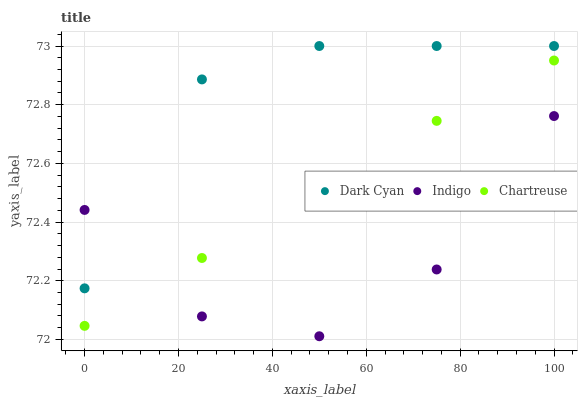Does Indigo have the minimum area under the curve?
Answer yes or no. Yes. Does Dark Cyan have the maximum area under the curve?
Answer yes or no. Yes. Does Chartreuse have the minimum area under the curve?
Answer yes or no. No. Does Chartreuse have the maximum area under the curve?
Answer yes or no. No. Is Chartreuse the smoothest?
Answer yes or no. Yes. Is Indigo the roughest?
Answer yes or no. Yes. Is Indigo the smoothest?
Answer yes or no. No. Is Chartreuse the roughest?
Answer yes or no. No. Does Indigo have the lowest value?
Answer yes or no. Yes. Does Chartreuse have the lowest value?
Answer yes or no. No. Does Dark Cyan have the highest value?
Answer yes or no. Yes. Does Chartreuse have the highest value?
Answer yes or no. No. Is Chartreuse less than Dark Cyan?
Answer yes or no. Yes. Is Dark Cyan greater than Chartreuse?
Answer yes or no. Yes. Does Chartreuse intersect Indigo?
Answer yes or no. Yes. Is Chartreuse less than Indigo?
Answer yes or no. No. Is Chartreuse greater than Indigo?
Answer yes or no. No. Does Chartreuse intersect Dark Cyan?
Answer yes or no. No. 